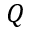Convert formula to latex. <formula><loc_0><loc_0><loc_500><loc_500>Q</formula> 